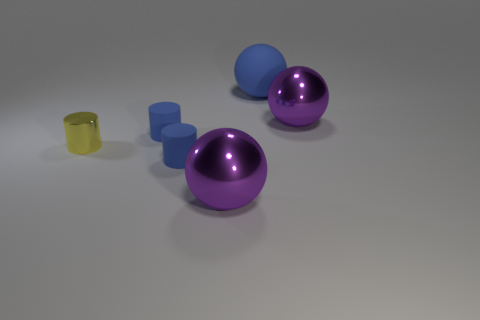Subtract all small yellow cylinders. How many cylinders are left? 2 Subtract all blue balls. How many blue cylinders are left? 2 Subtract 1 balls. How many balls are left? 2 Add 3 large things. How many objects exist? 9 Subtract all red cylinders. Subtract all green cubes. How many cylinders are left? 3 Add 4 cylinders. How many cylinders exist? 7 Subtract 0 red spheres. How many objects are left? 6 Subtract all small rubber cylinders. Subtract all metal objects. How many objects are left? 1 Add 5 tiny yellow cylinders. How many tiny yellow cylinders are left? 6 